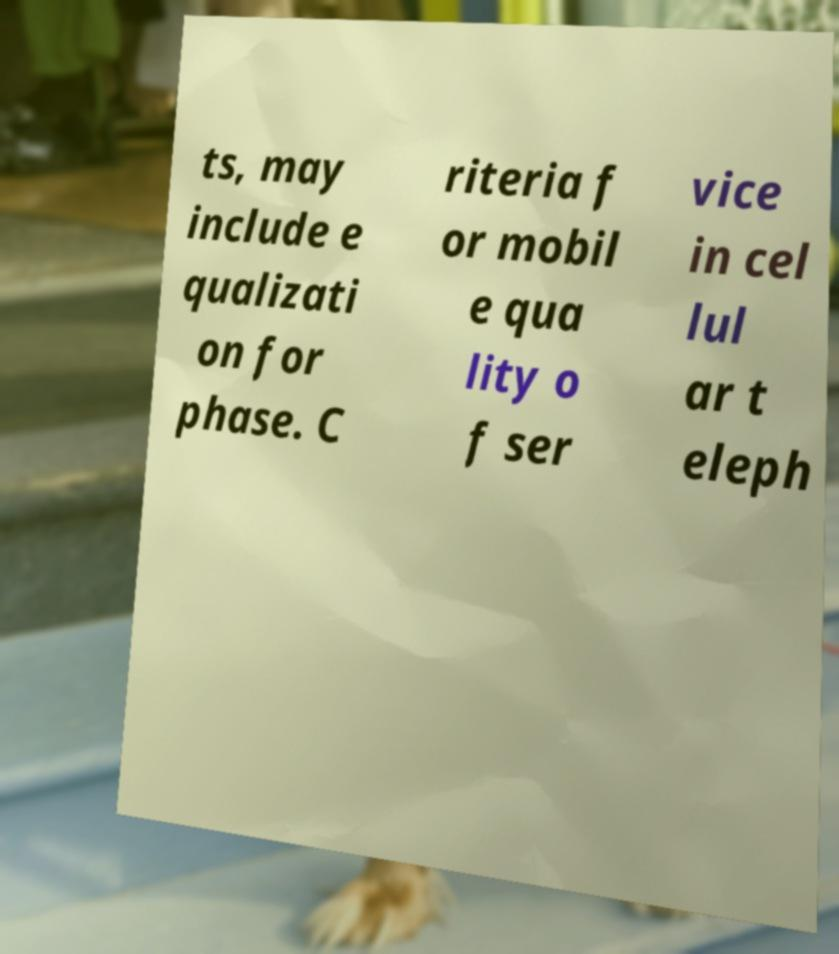Can you read and provide the text displayed in the image?This photo seems to have some interesting text. Can you extract and type it out for me? ts, may include e qualizati on for phase. C riteria f or mobil e qua lity o f ser vice in cel lul ar t eleph 